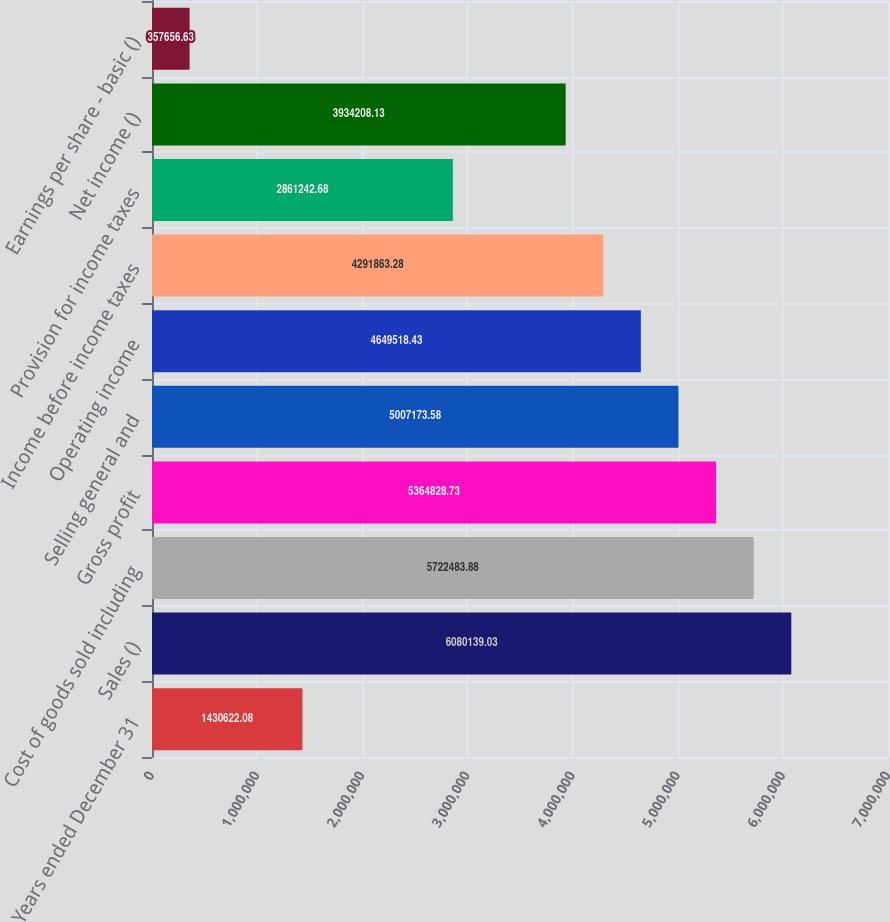<chart> <loc_0><loc_0><loc_500><loc_500><bar_chart><fcel>Years ended December 31<fcel>Sales ()<fcel>Cost of goods sold including<fcel>Gross profit<fcel>Selling general and<fcel>Operating income<fcel>Income before income taxes<fcel>Provision for income taxes<fcel>Net income ()<fcel>Earnings per share - basic ()<nl><fcel>1.43062e+06<fcel>6.08014e+06<fcel>5.72248e+06<fcel>5.36483e+06<fcel>5.00717e+06<fcel>4.64952e+06<fcel>4.29186e+06<fcel>2.86124e+06<fcel>3.93421e+06<fcel>357657<nl></chart> 